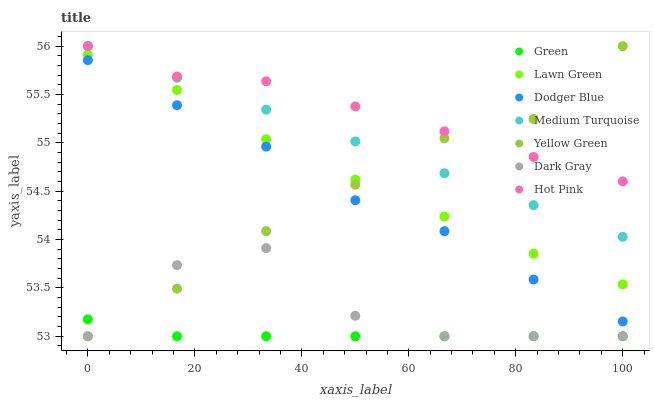Does Green have the minimum area under the curve?
Answer yes or no. Yes. Does Hot Pink have the maximum area under the curve?
Answer yes or no. Yes. Does Yellow Green have the minimum area under the curve?
Answer yes or no. No. Does Yellow Green have the maximum area under the curve?
Answer yes or no. No. Is Medium Turquoise the smoothest?
Answer yes or no. Yes. Is Dark Gray the roughest?
Answer yes or no. Yes. Is Yellow Green the smoothest?
Answer yes or no. No. Is Yellow Green the roughest?
Answer yes or no. No. Does Yellow Green have the lowest value?
Answer yes or no. Yes. Does Hot Pink have the lowest value?
Answer yes or no. No. Does Medium Turquoise have the highest value?
Answer yes or no. Yes. Does Yellow Green have the highest value?
Answer yes or no. No. Is Dark Gray less than Medium Turquoise?
Answer yes or no. Yes. Is Dodger Blue greater than Dark Gray?
Answer yes or no. Yes. Does Yellow Green intersect Hot Pink?
Answer yes or no. Yes. Is Yellow Green less than Hot Pink?
Answer yes or no. No. Is Yellow Green greater than Hot Pink?
Answer yes or no. No. Does Dark Gray intersect Medium Turquoise?
Answer yes or no. No. 